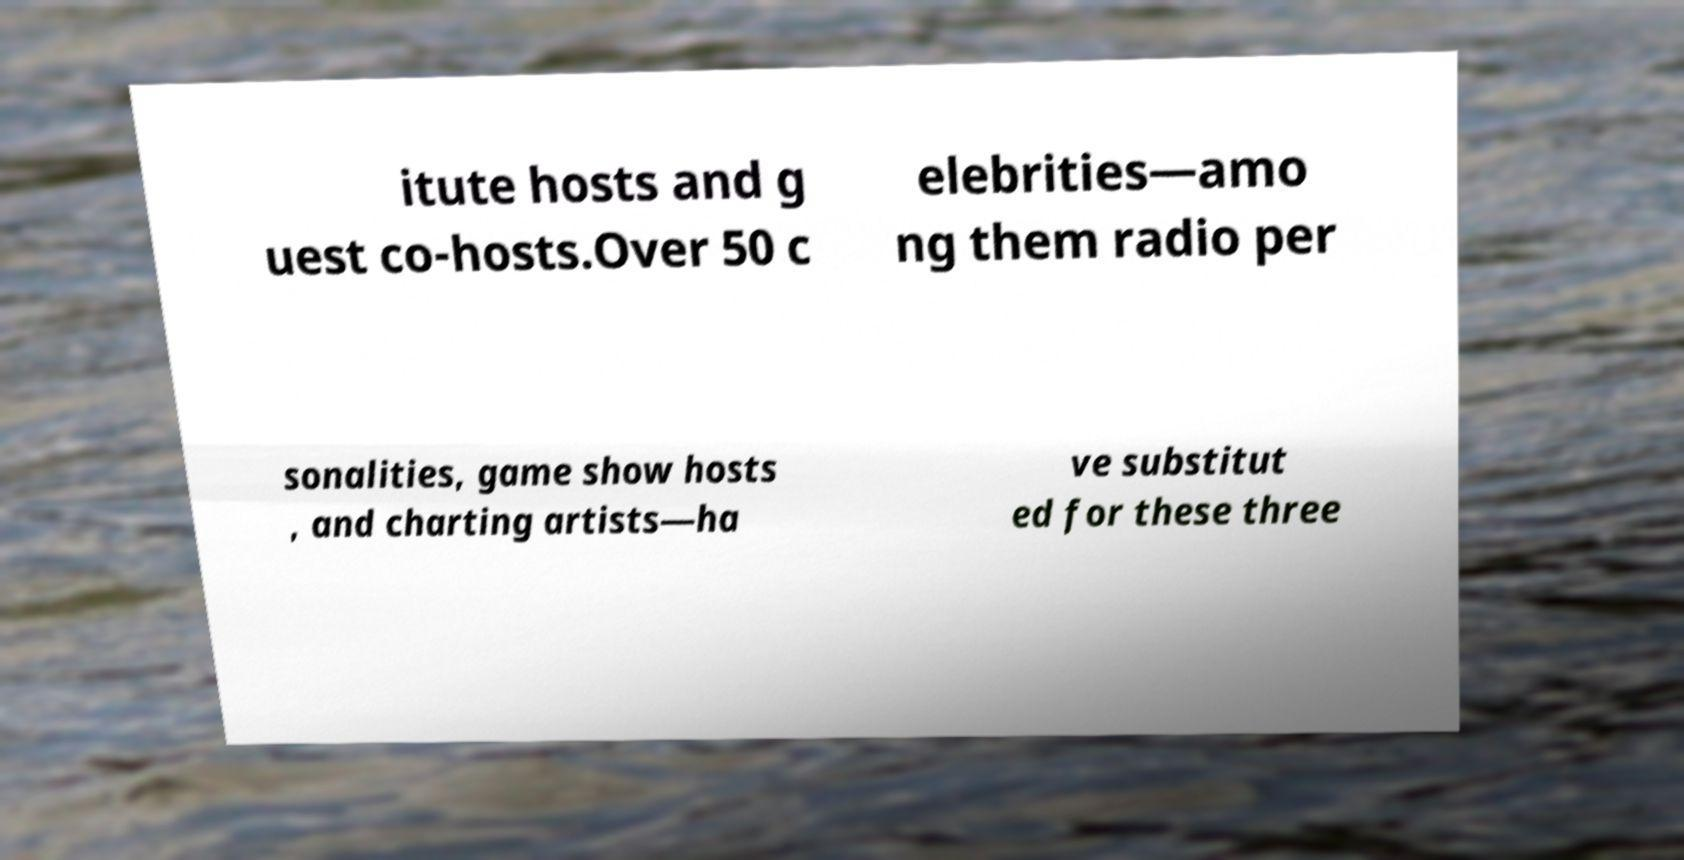I need the written content from this picture converted into text. Can you do that? itute hosts and g uest co-hosts.Over 50 c elebrities—amo ng them radio per sonalities, game show hosts , and charting artists—ha ve substitut ed for these three 